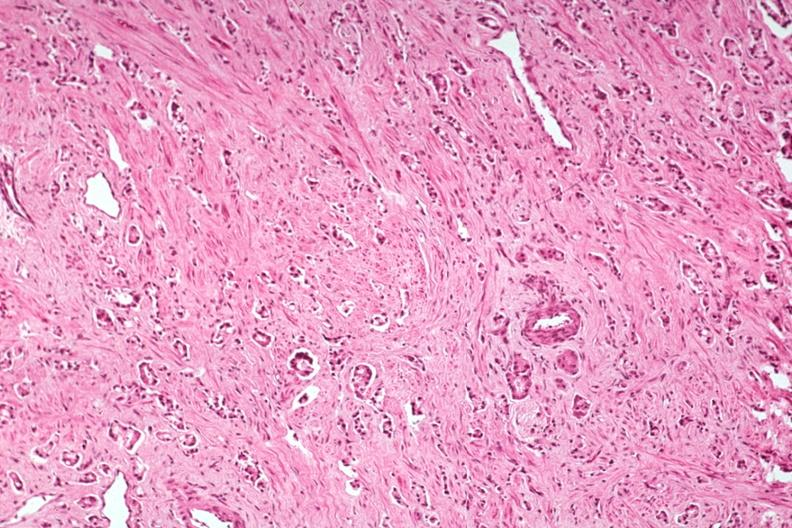s adenocarcinoma present?
Answer the question using a single word or phrase. Yes 